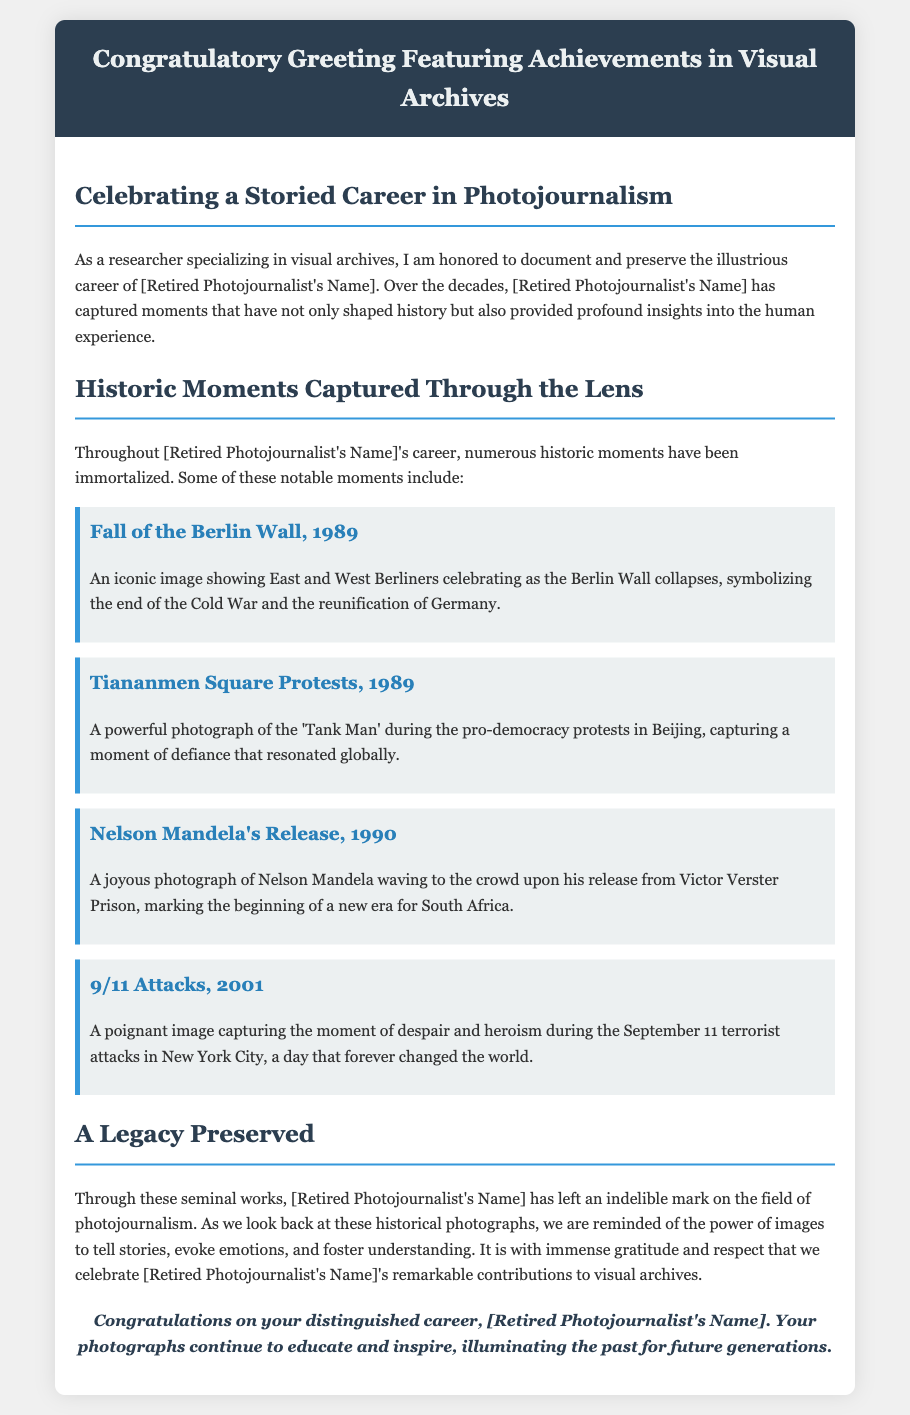What is the title of the document? The title of the document is featured in the header section of the greeting card.
Answer: Congratulatory Greeting Featuring Achievements in Visual Archives Who is being celebrated in this greeting card? The document mentions the name of the retired photojournalist multiple times.
Answer: [Retired Photojournalist's Name] In which year did the fall of the Berlin Wall occur? The document specifically states the year associated with this historical moment in the photo-highlight section.
Answer: 1989 What event does the phrase ‘Tank Man’ refer to? The document links this phrase to a significant historical moment captured by the photojournalist.
Answer: Tiananmen Square Protests What notable moment is depicted in the photograph from 1990? The text provides the year and event related to a significant photograph taken by the photojournalist.
Answer: Nelson Mandela's Release How many historical moments are highlighted in the document? The content reveals the number of prominent moments included in the photo highlights.
Answer: Four What is emphasized as the power of images in the document? The document discusses the impact of images in telling stories, evoking emotions, and fostering understanding.
Answer: The power of images What style is the closing remarks written in? The document specifies the writing style used in the final section of the content.
Answer: Italic 